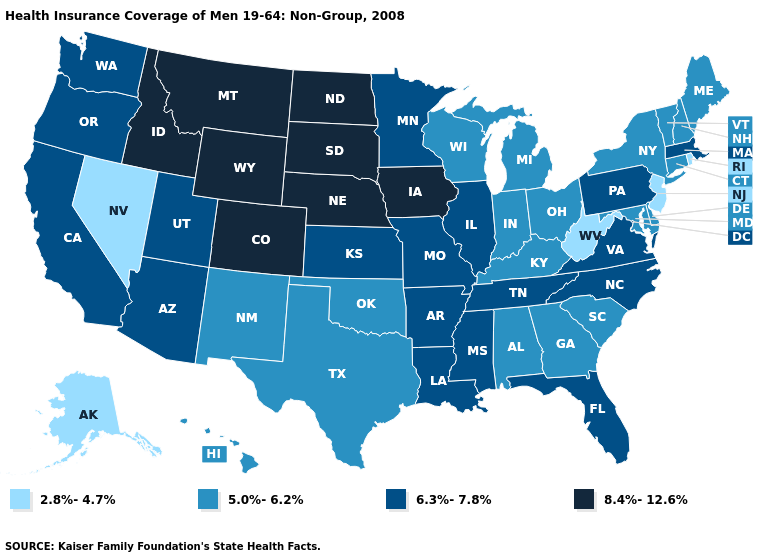What is the lowest value in the MidWest?
Short answer required. 5.0%-6.2%. Which states hav the highest value in the South?
Be succinct. Arkansas, Florida, Louisiana, Mississippi, North Carolina, Tennessee, Virginia. Name the states that have a value in the range 2.8%-4.7%?
Give a very brief answer. Alaska, Nevada, New Jersey, Rhode Island, West Virginia. Does West Virginia have the lowest value in the South?
Short answer required. Yes. Does West Virginia have the lowest value in the South?
Quick response, please. Yes. What is the value of Washington?
Give a very brief answer. 6.3%-7.8%. Does New Jersey have the same value as South Dakota?
Quick response, please. No. Does the map have missing data?
Give a very brief answer. No. Among the states that border Kansas , does Nebraska have the highest value?
Short answer required. Yes. Is the legend a continuous bar?
Be succinct. No. Does the first symbol in the legend represent the smallest category?
Quick response, please. Yes. Does Utah have the lowest value in the West?
Concise answer only. No. What is the highest value in the USA?
Write a very short answer. 8.4%-12.6%. Name the states that have a value in the range 2.8%-4.7%?
Short answer required. Alaska, Nevada, New Jersey, Rhode Island, West Virginia. What is the value of North Carolina?
Answer briefly. 6.3%-7.8%. 